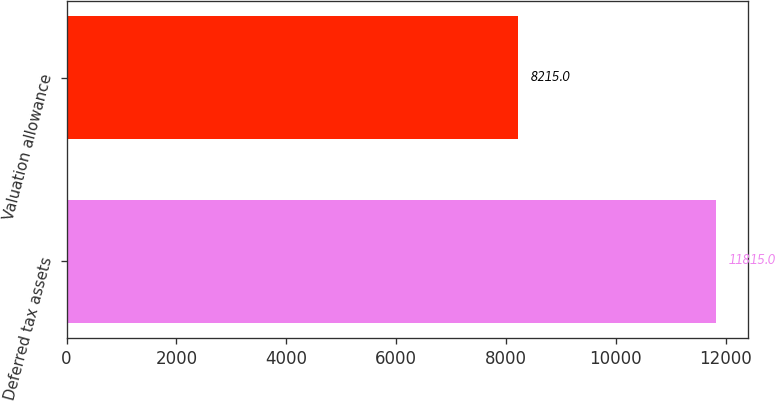Convert chart to OTSL. <chart><loc_0><loc_0><loc_500><loc_500><bar_chart><fcel>Deferred tax assets<fcel>Valuation allowance<nl><fcel>11815<fcel>8215<nl></chart> 